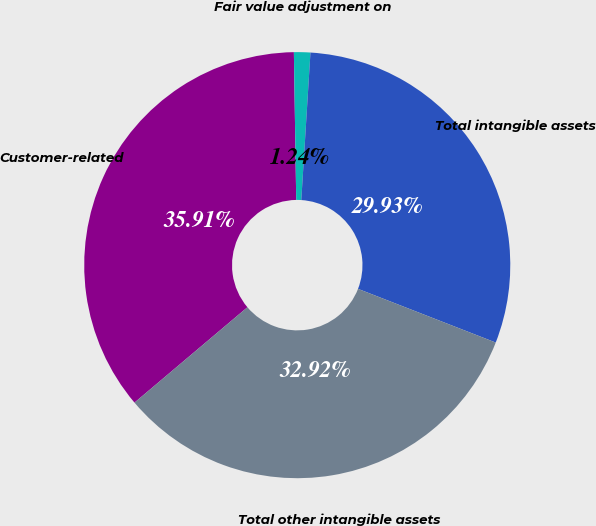<chart> <loc_0><loc_0><loc_500><loc_500><pie_chart><fcel>Customer-related<fcel>Fair value adjustment on<fcel>Total intangible assets<fcel>Total other intangible assets<nl><fcel>35.91%<fcel>1.24%<fcel>29.93%<fcel>32.92%<nl></chart> 